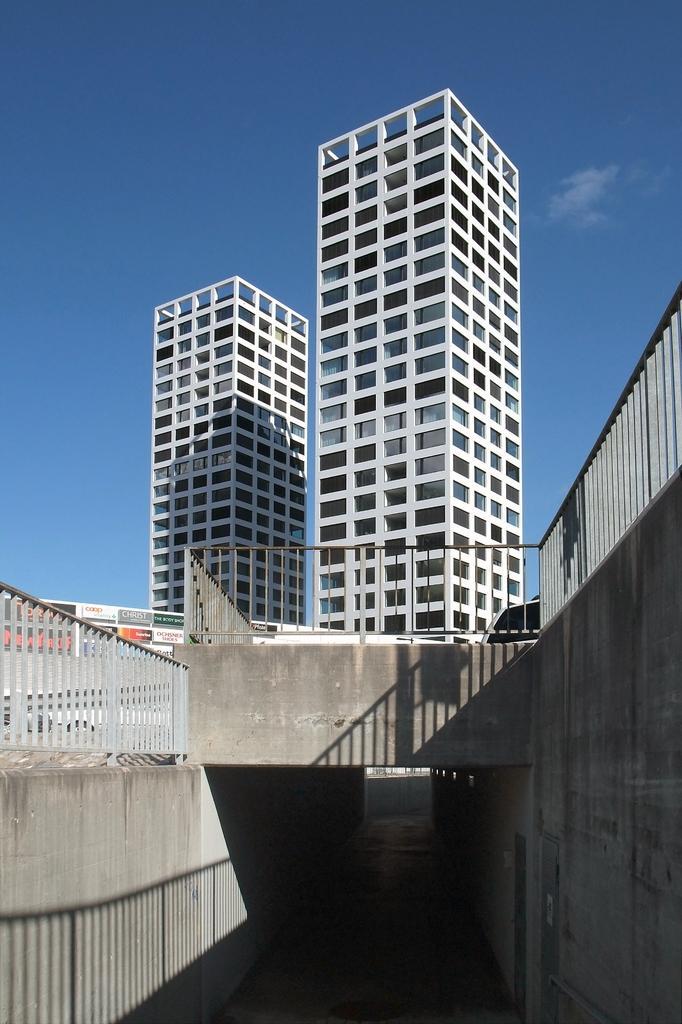Could you give a brief overview of what you see in this image? In front of the image there is a tunnel, on top of the tunnel there is a bridge with metal rod fence, behind the fence there are buildings, in the sky there are clouds. 